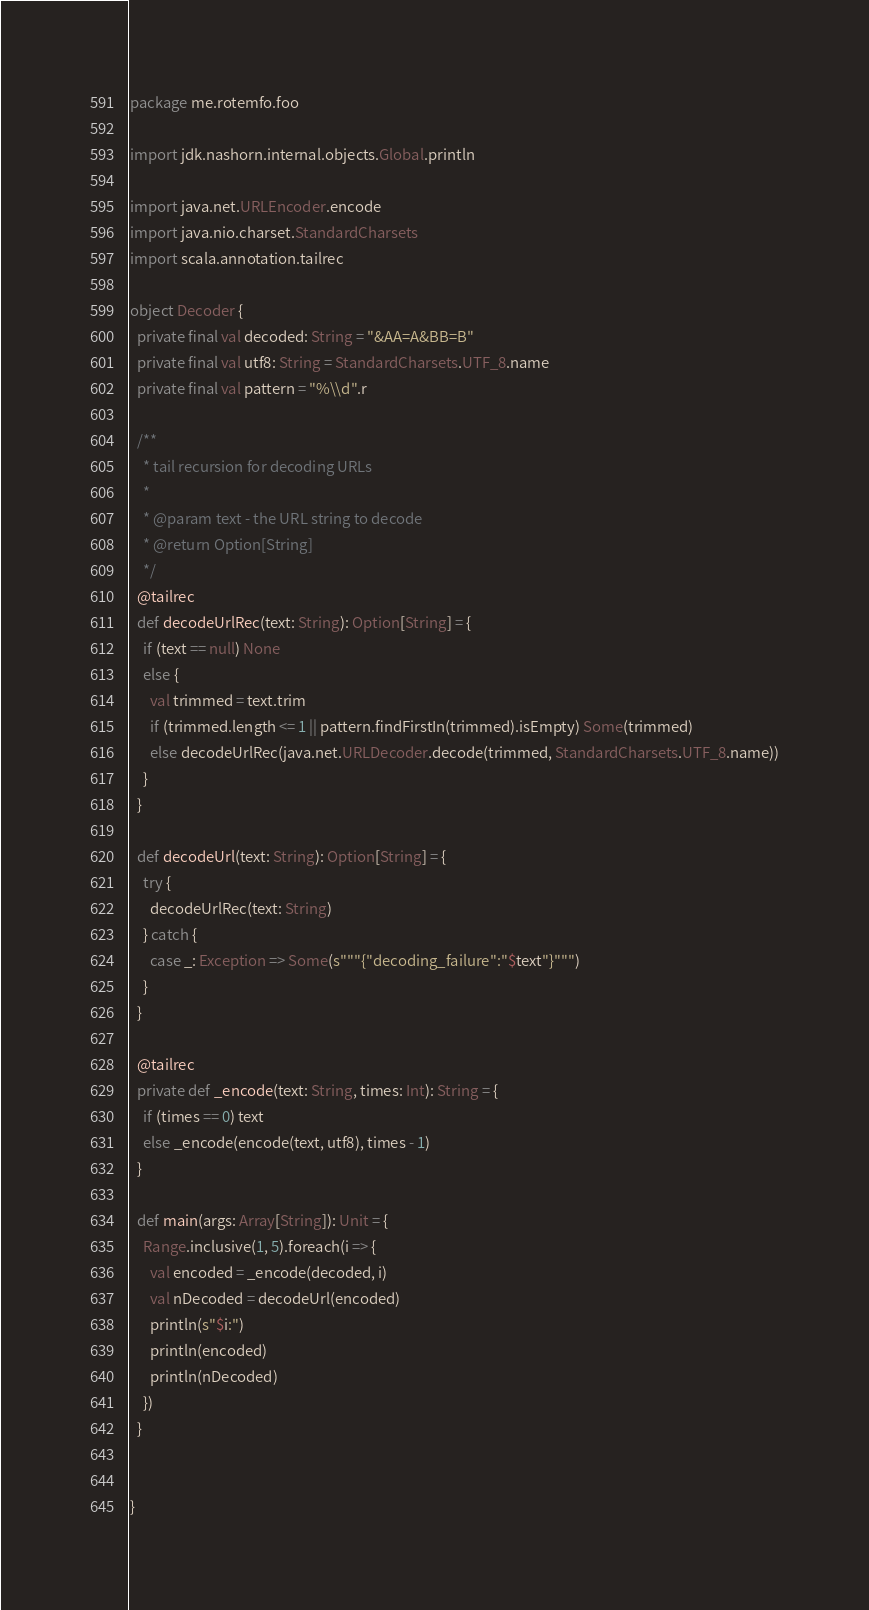Convert code to text. <code><loc_0><loc_0><loc_500><loc_500><_Scala_>package me.rotemfo.foo

import jdk.nashorn.internal.objects.Global.println

import java.net.URLEncoder.encode
import java.nio.charset.StandardCharsets
import scala.annotation.tailrec

object Decoder {
  private final val decoded: String = "&AA=A&BB=B"
  private final val utf8: String = StandardCharsets.UTF_8.name
  private final val pattern = "%\\d".r

  /**
    * tail recursion for decoding URLs
    *
    * @param text - the URL string to decode
    * @return Option[String]
    */
  @tailrec
  def decodeUrlRec(text: String): Option[String] = {
    if (text == null) None
    else {
      val trimmed = text.trim
      if (trimmed.length <= 1 || pattern.findFirstIn(trimmed).isEmpty) Some(trimmed)
      else decodeUrlRec(java.net.URLDecoder.decode(trimmed, StandardCharsets.UTF_8.name))
    }
  }

  def decodeUrl(text: String): Option[String] = {
    try {
      decodeUrlRec(text: String)
    } catch {
      case _: Exception => Some(s"""{"decoding_failure":"$text"}""")
    }
  }

  @tailrec
  private def _encode(text: String, times: Int): String = {
    if (times == 0) text
    else _encode(encode(text, utf8), times - 1)
  }

  def main(args: Array[String]): Unit = {
    Range.inclusive(1, 5).foreach(i => {
      val encoded = _encode(decoded, i)
      val nDecoded = decodeUrl(encoded)
      println(s"$i:")
      println(encoded)
      println(nDecoded)
    })
  }


}
</code> 